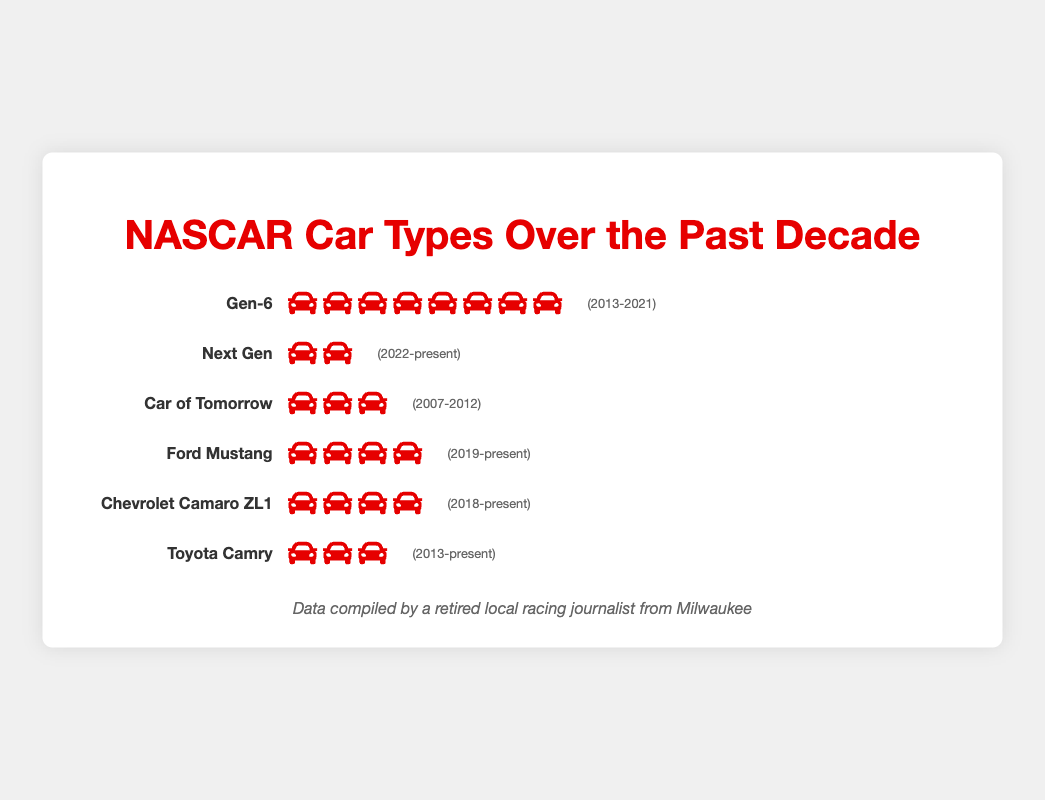What is the most common car type in NASCAR events over the past decade? The Gen-6 car type has the highest number of icons in the Isotype Plot, indicating it is the most common car type.
Answer: Gen-6 Which car types have been used since 2013? The car types used since 2013 have associated years that include or extend from 2013. These are Gen-6, Toyota Camry, Ford Mustang, Chevrolet Camaro ZL1, and Next Gen.
Answer: Gen-6, Toyota Camry, Ford Mustang, Chevrolet Camaro ZL1, Next Gen How many different car types are depicted in the figure? The figure displays six distinct car types, each with its own row of icons and labels.
Answer: Six Which car type has the fewest counts? The Next Gen car type has the fewest icons, indicating it has the lowest count.
Answer: Next Gen How many years did the Car of Tomorrow participate in NASCAR events? The Car of Tomorrow was used from 2007 to 2012, which is a span of 6 years.
Answer: 6 years Which car type has been in use since 2019? The car types that have been in use since 2019 are those listed with years extending from 2019 onwards. These include the Ford Mustang and Next Gen.
Answer: Ford Mustang, Next Gen Compare the counts of Gen-6 and Chevrolet Camaro ZL1. Which is higher and by how much? The Gen-6 has 80 counts while Chevrolet Camaro ZL1 has 35 counts. The difference is 80 - 35 = 45.
Answer: Gen-6 by 45 What is the combined count of the Ford Mustang and Toyota Camry? The Ford Mustang has 40 counts, and the Toyota Camry has 30 counts. Their combined count is 40 + 30 = 70.
Answer: 70 Which car types have a count below 40? The car types with counts below 40 are the Next Gen, Car of Tomorrow, Chevrolet Camaro ZL1, and Toyota Camry.
Answer: Next Gen, Car of Tomorrow, Chevrolet Camaro ZL1, Toyota Camry Calculate the average count for the car types that have been in use since 2018. The car types used since 2018 are Chevrolet Camaro ZL1, Toyota Camry, Ford Mustang, and Next Gen. Their counts are 35, 30, 40, and 20 respectively. The average count is (35 + 30 + 40 + 20) / 4 = 125 / 4 = 31.25.
Answer: 31.25 